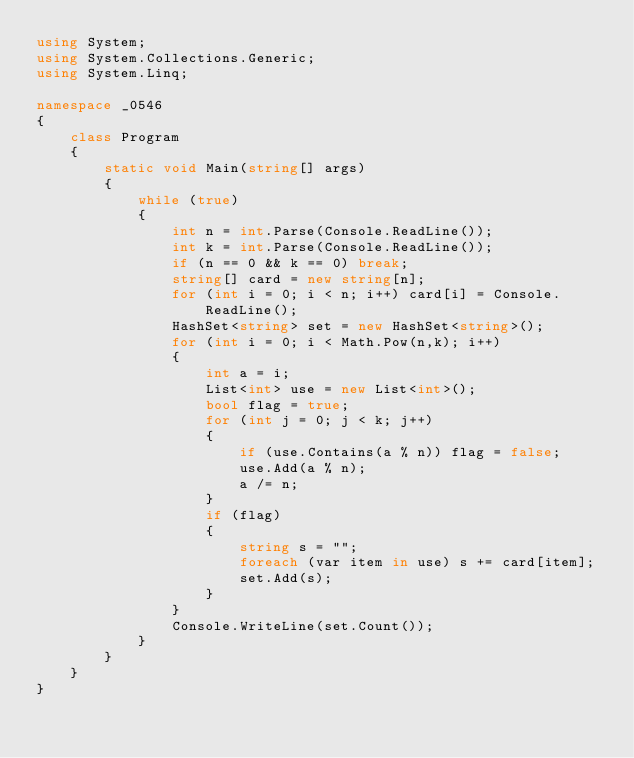<code> <loc_0><loc_0><loc_500><loc_500><_C#_>using System;
using System.Collections.Generic;
using System.Linq;

namespace _0546
{
    class Program
    {
        static void Main(string[] args)
        {
            while (true)
            {
                int n = int.Parse(Console.ReadLine());
                int k = int.Parse(Console.ReadLine());
                if (n == 0 && k == 0) break;
                string[] card = new string[n];
                for (int i = 0; i < n; i++) card[i] = Console.ReadLine();
                HashSet<string> set = new HashSet<string>();
                for (int i = 0; i < Math.Pow(n,k); i++)
                {
                    int a = i;
                    List<int> use = new List<int>();
                    bool flag = true;
                    for (int j = 0; j < k; j++)
                    {
                        if (use.Contains(a % n)) flag = false;
                        use.Add(a % n);
                        a /= n;
                    }
                    if (flag)
                    {
                        string s = "";
                        foreach (var item in use) s += card[item];
                        set.Add(s);
                    }
                }
                Console.WriteLine(set.Count());
            }
        }
    }
}
</code> 